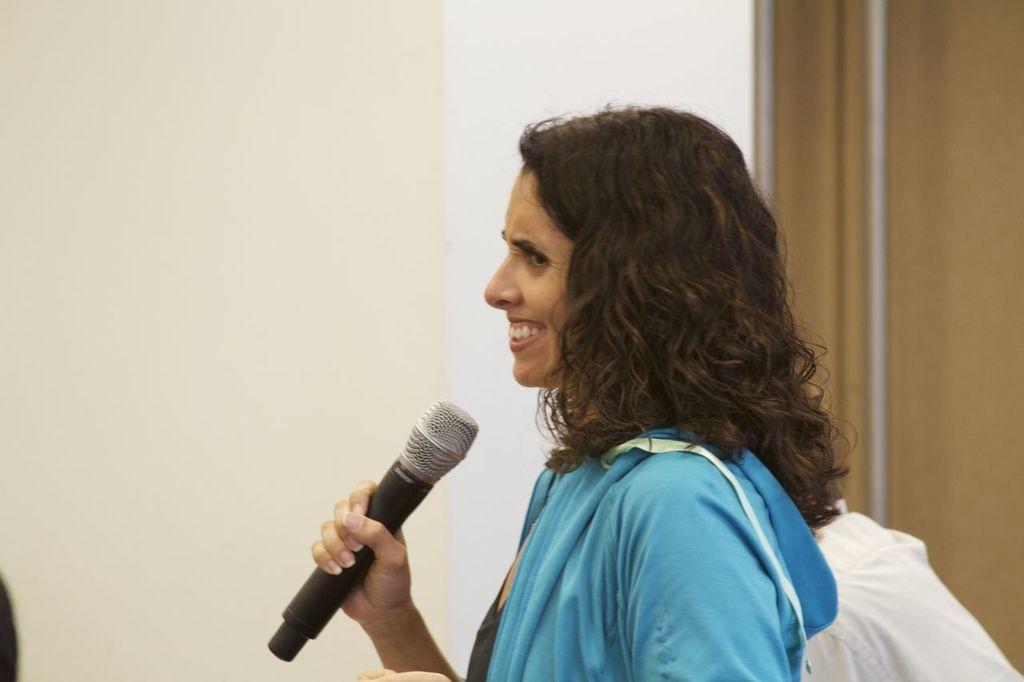Can you describe this image briefly? This picture shows a woman holding a mic in her hand and smiling. In a background there is a wall here 